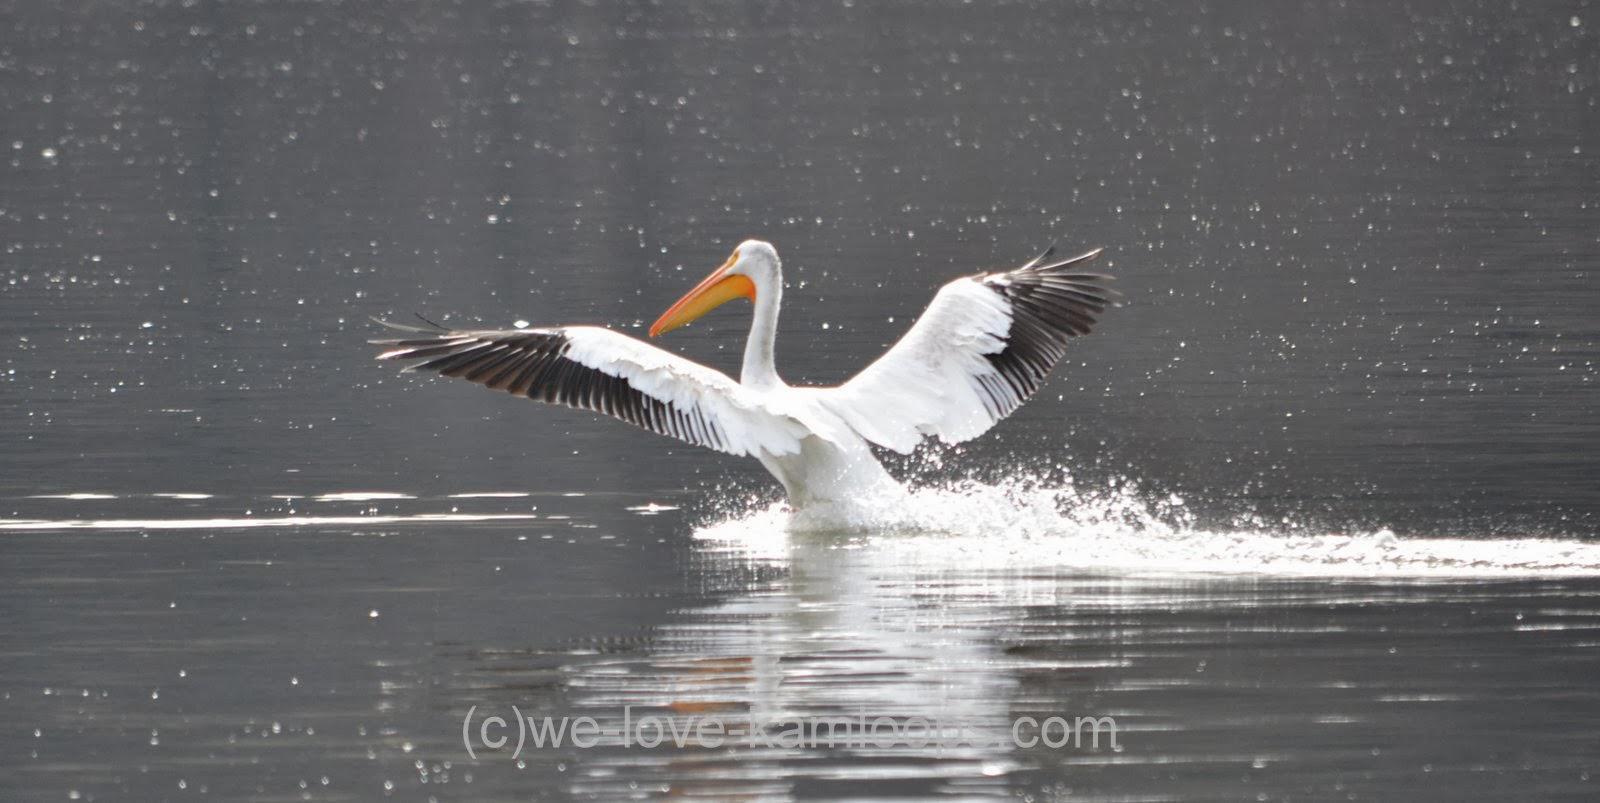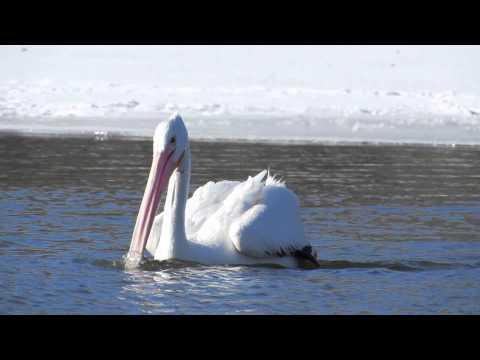The first image is the image on the left, the second image is the image on the right. Considering the images on both sides, is "At least one of the birds has a fish in its mouth." valid? Answer yes or no. No. The first image is the image on the left, the second image is the image on the right. Given the left and right images, does the statement "The bird in the right image is eating a fish." hold true? Answer yes or no. No. 